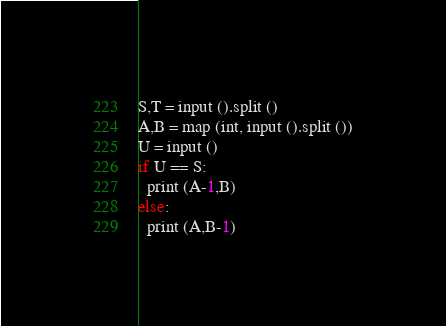<code> <loc_0><loc_0><loc_500><loc_500><_Python_>S,T = input ().split ()
A,B = map (int, input ().split ())
U = input ()
if U == S:
  print (A-1,B)
else:
  print (A,B-1)</code> 